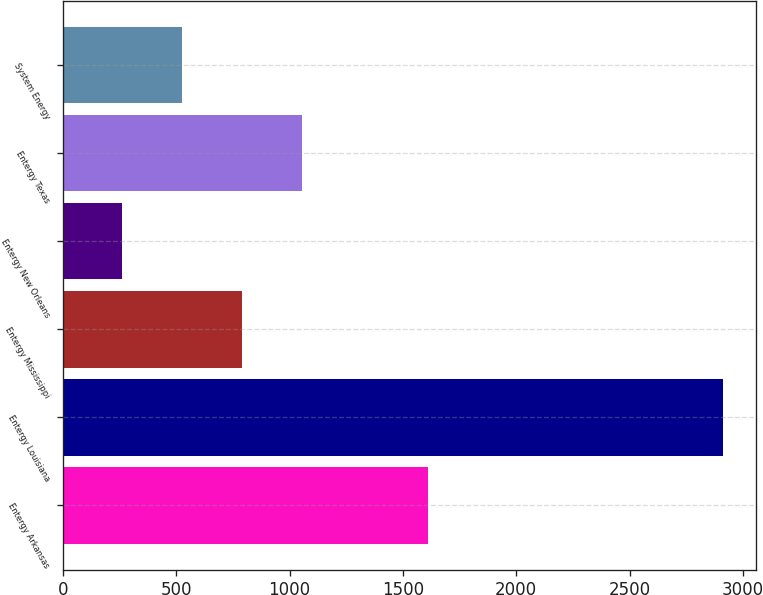<chart> <loc_0><loc_0><loc_500><loc_500><bar_chart><fcel>Entergy Arkansas<fcel>Entergy Louisiana<fcel>Entergy Mississippi<fcel>Entergy New Orleans<fcel>Entergy Texas<fcel>System Energy<nl><fcel>1609<fcel>2910<fcel>789.2<fcel>259<fcel>1054.3<fcel>524.1<nl></chart> 